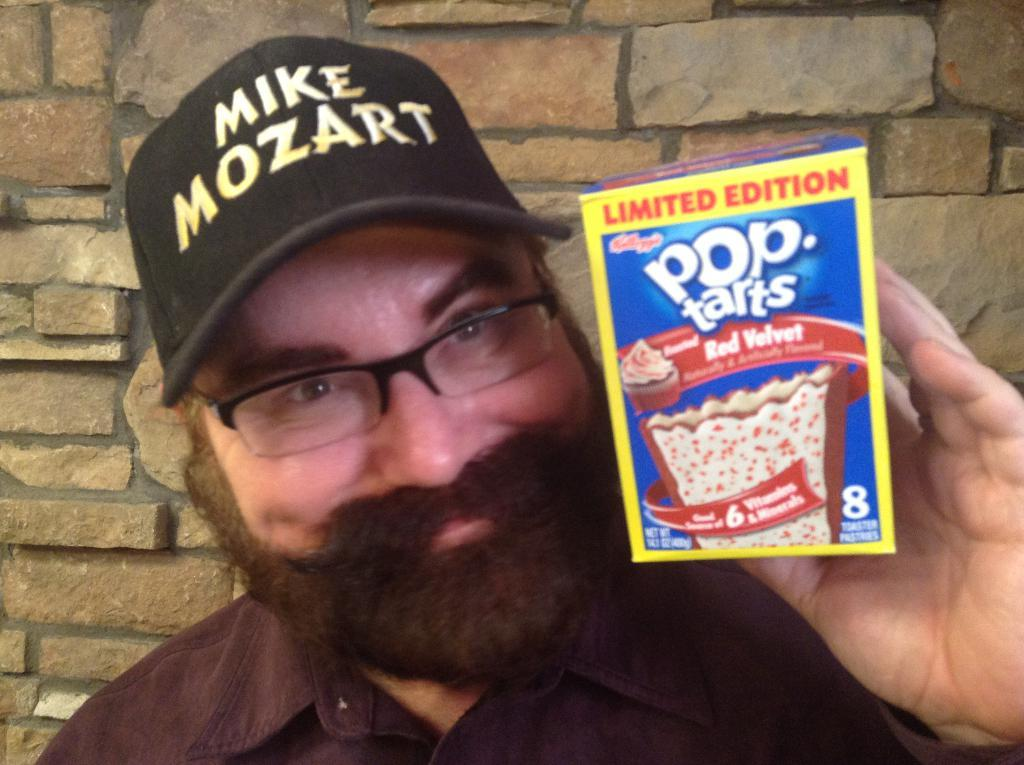Who is present in the image? There is a man in the image. What is the man wearing on his face? The man is wearing spectacles. What is the man wearing on his head? The man is wearing a cap. What is the man holding in his hand? The man is holding a box. What is the man's facial expression? The man is smiling. What can be seen in the background of the image? There is a wall in the background of the image. What type of fish can be seen folding clothes in the image? There is no fish or folding clothes present in the image; it features a man wearing spectacles, a cap, and holding a box. 